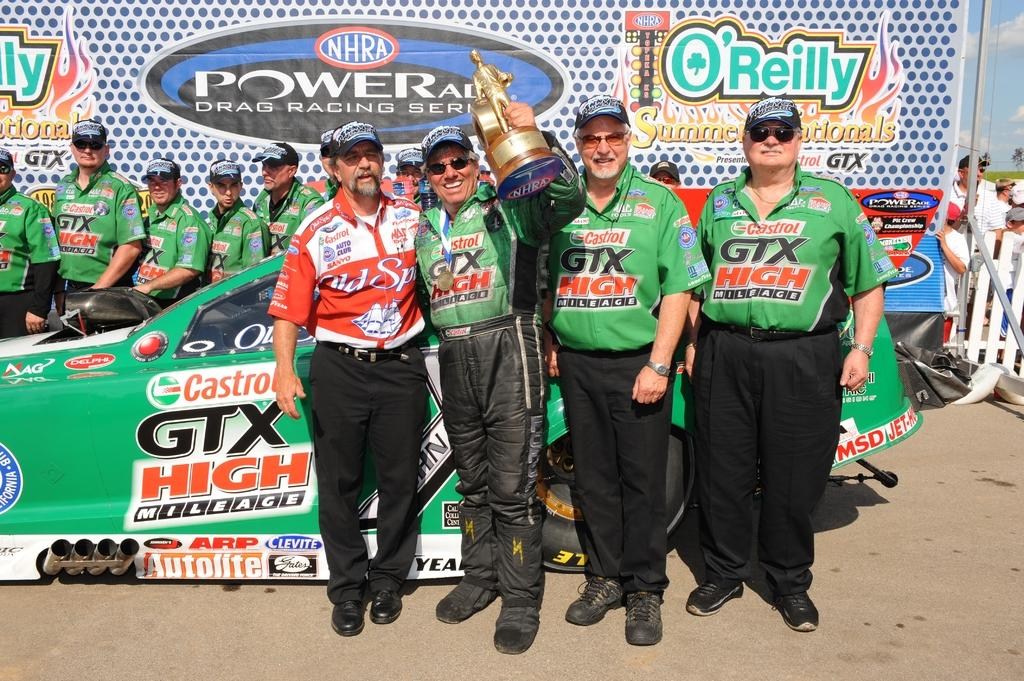<image>
Offer a succinct explanation of the picture presented. The race team is sponsored by O'reilly auto parts. 